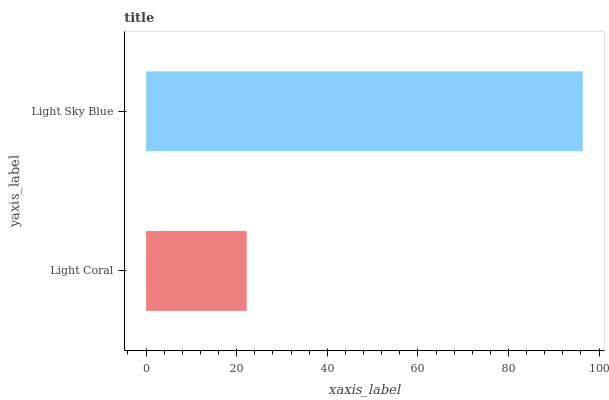Is Light Coral the minimum?
Answer yes or no. Yes. Is Light Sky Blue the maximum?
Answer yes or no. Yes. Is Light Sky Blue the minimum?
Answer yes or no. No. Is Light Sky Blue greater than Light Coral?
Answer yes or no. Yes. Is Light Coral less than Light Sky Blue?
Answer yes or no. Yes. Is Light Coral greater than Light Sky Blue?
Answer yes or no. No. Is Light Sky Blue less than Light Coral?
Answer yes or no. No. Is Light Sky Blue the high median?
Answer yes or no. Yes. Is Light Coral the low median?
Answer yes or no. Yes. Is Light Coral the high median?
Answer yes or no. No. Is Light Sky Blue the low median?
Answer yes or no. No. 